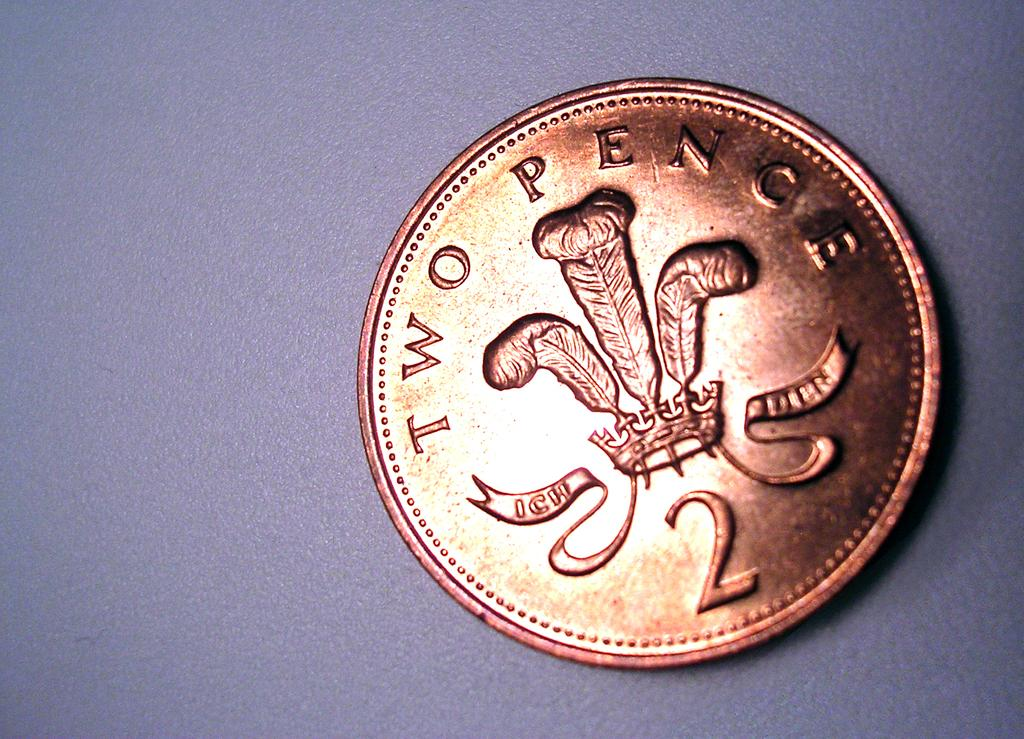<image>
Relay a brief, clear account of the picture shown. A copper colored coin is labeled with Two Pence and the number 2. 